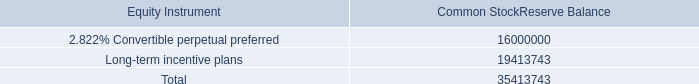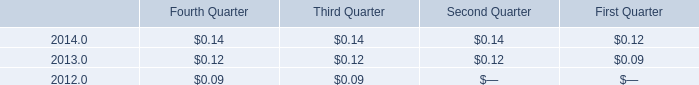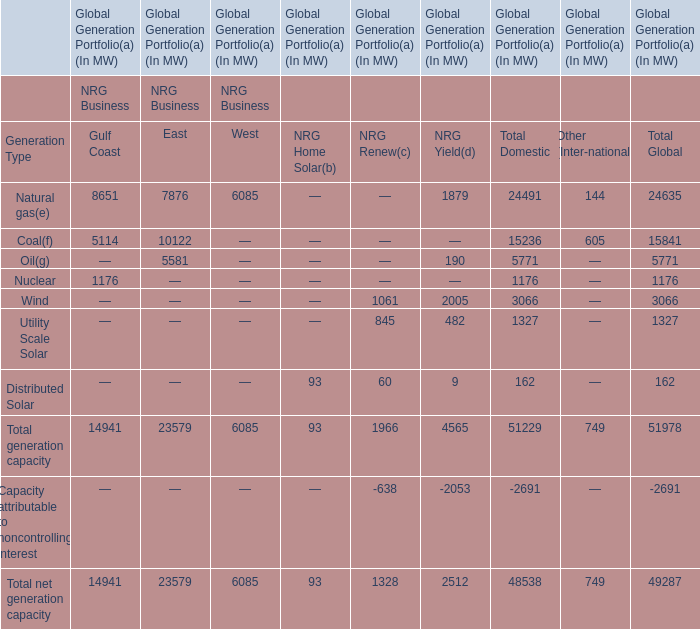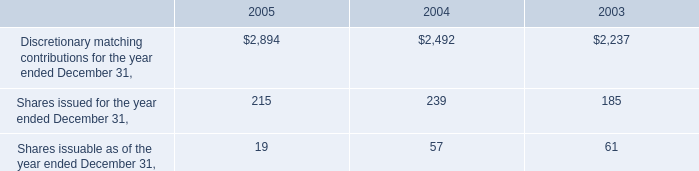what was the change in the the company interest-free loan outstanding to an officer in 2005 and 2004 
Computations: (97000 - 36000)
Answer: 61000.0. 